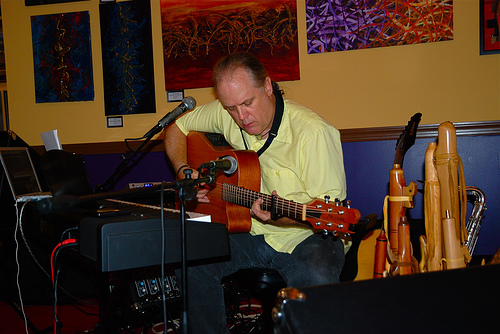<image>
Can you confirm if the piano is behind the man? No. The piano is not behind the man. From this viewpoint, the piano appears to be positioned elsewhere in the scene. Where is the yellow wall in relation to the balding man? Is it in front of the balding man? No. The yellow wall is not in front of the balding man. The spatial positioning shows a different relationship between these objects. 